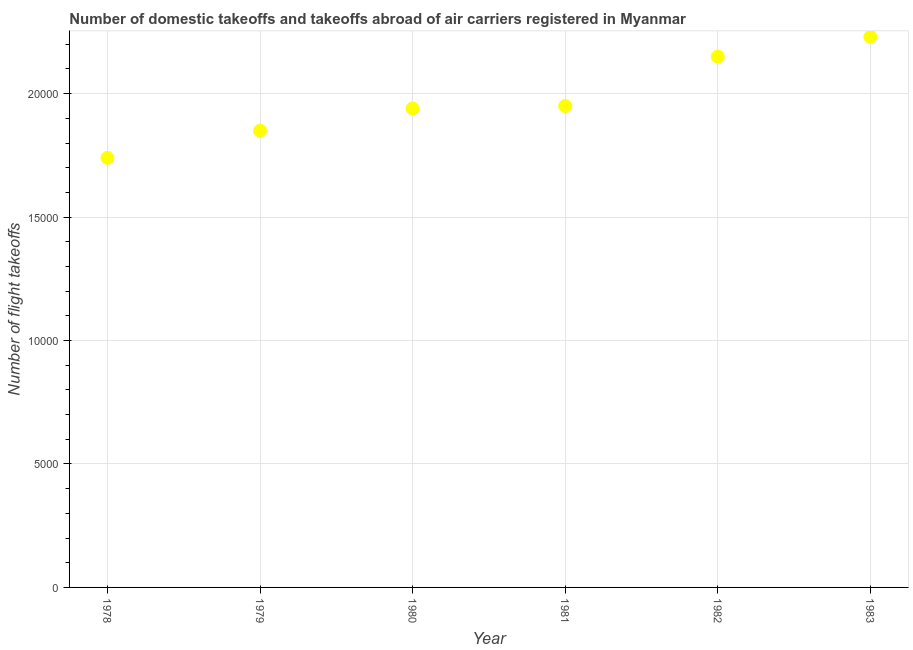What is the number of flight takeoffs in 1982?
Your response must be concise. 2.15e+04. Across all years, what is the maximum number of flight takeoffs?
Ensure brevity in your answer.  2.23e+04. Across all years, what is the minimum number of flight takeoffs?
Ensure brevity in your answer.  1.74e+04. In which year was the number of flight takeoffs maximum?
Your answer should be compact. 1983. In which year was the number of flight takeoffs minimum?
Give a very brief answer. 1978. What is the sum of the number of flight takeoffs?
Your response must be concise. 1.19e+05. What is the difference between the number of flight takeoffs in 1981 and 1983?
Your response must be concise. -2800. What is the average number of flight takeoffs per year?
Provide a succinct answer. 1.98e+04. What is the median number of flight takeoffs?
Offer a terse response. 1.94e+04. In how many years, is the number of flight takeoffs greater than 13000 ?
Your response must be concise. 6. What is the ratio of the number of flight takeoffs in 1982 to that in 1983?
Provide a succinct answer. 0.96. What is the difference between the highest and the second highest number of flight takeoffs?
Offer a terse response. 800. Is the sum of the number of flight takeoffs in 1978 and 1979 greater than the maximum number of flight takeoffs across all years?
Provide a succinct answer. Yes. What is the difference between the highest and the lowest number of flight takeoffs?
Your answer should be compact. 4900. Does the number of flight takeoffs monotonically increase over the years?
Your response must be concise. Yes. What is the difference between two consecutive major ticks on the Y-axis?
Give a very brief answer. 5000. Are the values on the major ticks of Y-axis written in scientific E-notation?
Provide a succinct answer. No. Does the graph contain any zero values?
Offer a very short reply. No. What is the title of the graph?
Give a very brief answer. Number of domestic takeoffs and takeoffs abroad of air carriers registered in Myanmar. What is the label or title of the X-axis?
Your answer should be very brief. Year. What is the label or title of the Y-axis?
Give a very brief answer. Number of flight takeoffs. What is the Number of flight takeoffs in 1978?
Ensure brevity in your answer.  1.74e+04. What is the Number of flight takeoffs in 1979?
Ensure brevity in your answer.  1.85e+04. What is the Number of flight takeoffs in 1980?
Your answer should be very brief. 1.94e+04. What is the Number of flight takeoffs in 1981?
Offer a very short reply. 1.95e+04. What is the Number of flight takeoffs in 1982?
Your answer should be compact. 2.15e+04. What is the Number of flight takeoffs in 1983?
Offer a terse response. 2.23e+04. What is the difference between the Number of flight takeoffs in 1978 and 1979?
Ensure brevity in your answer.  -1100. What is the difference between the Number of flight takeoffs in 1978 and 1980?
Your answer should be compact. -2000. What is the difference between the Number of flight takeoffs in 1978 and 1981?
Offer a terse response. -2100. What is the difference between the Number of flight takeoffs in 1978 and 1982?
Offer a very short reply. -4100. What is the difference between the Number of flight takeoffs in 1978 and 1983?
Offer a terse response. -4900. What is the difference between the Number of flight takeoffs in 1979 and 1980?
Ensure brevity in your answer.  -900. What is the difference between the Number of flight takeoffs in 1979 and 1981?
Your response must be concise. -1000. What is the difference between the Number of flight takeoffs in 1979 and 1982?
Make the answer very short. -3000. What is the difference between the Number of flight takeoffs in 1979 and 1983?
Make the answer very short. -3800. What is the difference between the Number of flight takeoffs in 1980 and 1981?
Your answer should be compact. -100. What is the difference between the Number of flight takeoffs in 1980 and 1982?
Ensure brevity in your answer.  -2100. What is the difference between the Number of flight takeoffs in 1980 and 1983?
Give a very brief answer. -2900. What is the difference between the Number of flight takeoffs in 1981 and 1982?
Your answer should be very brief. -2000. What is the difference between the Number of flight takeoffs in 1981 and 1983?
Offer a terse response. -2800. What is the difference between the Number of flight takeoffs in 1982 and 1983?
Make the answer very short. -800. What is the ratio of the Number of flight takeoffs in 1978 to that in 1979?
Your answer should be very brief. 0.94. What is the ratio of the Number of flight takeoffs in 1978 to that in 1980?
Make the answer very short. 0.9. What is the ratio of the Number of flight takeoffs in 1978 to that in 1981?
Your answer should be very brief. 0.89. What is the ratio of the Number of flight takeoffs in 1978 to that in 1982?
Provide a succinct answer. 0.81. What is the ratio of the Number of flight takeoffs in 1978 to that in 1983?
Offer a terse response. 0.78. What is the ratio of the Number of flight takeoffs in 1979 to that in 1980?
Offer a very short reply. 0.95. What is the ratio of the Number of flight takeoffs in 1979 to that in 1981?
Ensure brevity in your answer.  0.95. What is the ratio of the Number of flight takeoffs in 1979 to that in 1982?
Keep it short and to the point. 0.86. What is the ratio of the Number of flight takeoffs in 1979 to that in 1983?
Make the answer very short. 0.83. What is the ratio of the Number of flight takeoffs in 1980 to that in 1981?
Provide a succinct answer. 0.99. What is the ratio of the Number of flight takeoffs in 1980 to that in 1982?
Ensure brevity in your answer.  0.9. What is the ratio of the Number of flight takeoffs in 1980 to that in 1983?
Provide a succinct answer. 0.87. What is the ratio of the Number of flight takeoffs in 1981 to that in 1982?
Your answer should be compact. 0.91. What is the ratio of the Number of flight takeoffs in 1981 to that in 1983?
Offer a terse response. 0.87. What is the ratio of the Number of flight takeoffs in 1982 to that in 1983?
Give a very brief answer. 0.96. 